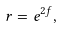<formula> <loc_0><loc_0><loc_500><loc_500>r = e ^ { 2 f } ,</formula> 